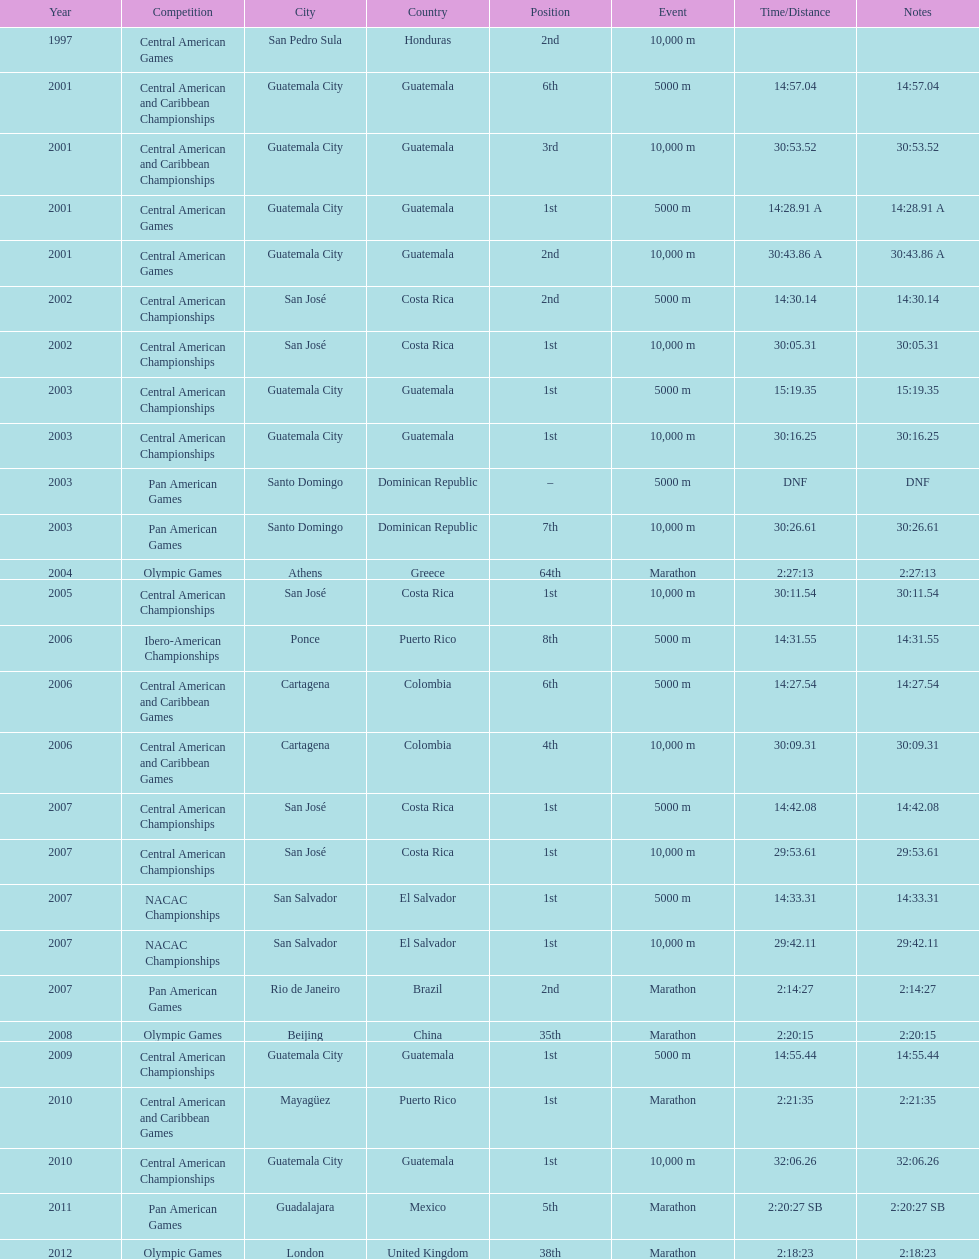Which event is listed more between the 10,000m and the 5000m? 10,000 m. 